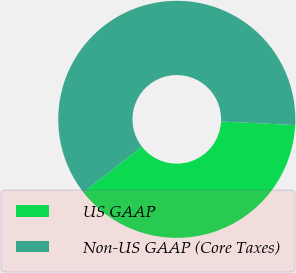<chart> <loc_0><loc_0><loc_500><loc_500><pie_chart><fcel>US GAAP<fcel>Non-US GAAP (Core Taxes)<nl><fcel>38.66%<fcel>61.34%<nl></chart> 